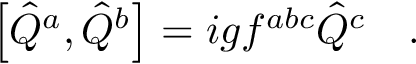<formula> <loc_0><loc_0><loc_500><loc_500>\left [ \hat { Q } ^ { a } , \hat { Q } ^ { b } \right ] = i g f ^ { a b c } \hat { Q } ^ { c } \quad .</formula> 